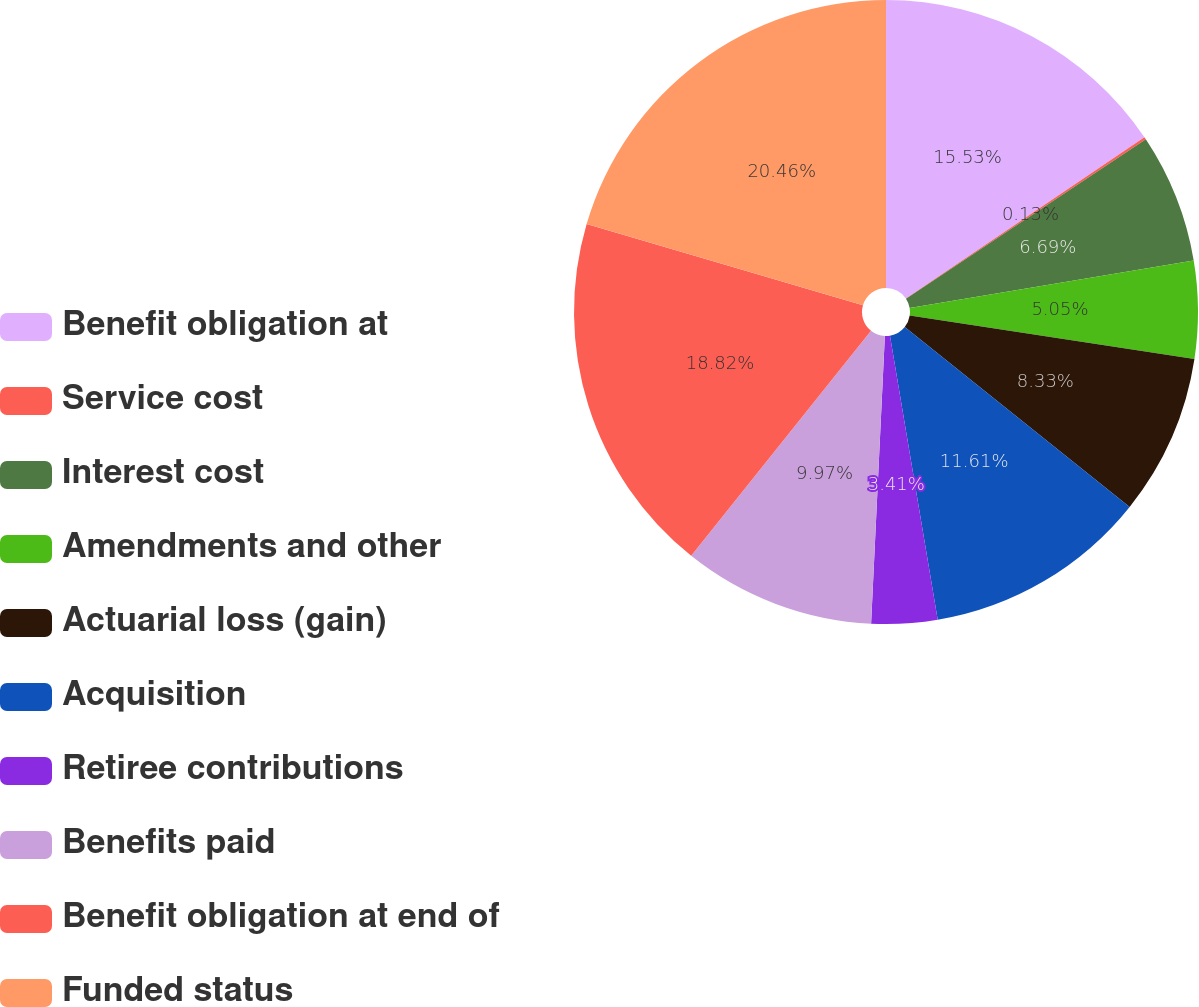<chart> <loc_0><loc_0><loc_500><loc_500><pie_chart><fcel>Benefit obligation at<fcel>Service cost<fcel>Interest cost<fcel>Amendments and other<fcel>Actuarial loss (gain)<fcel>Acquisition<fcel>Retiree contributions<fcel>Benefits paid<fcel>Benefit obligation at end of<fcel>Funded status<nl><fcel>15.53%<fcel>0.13%<fcel>6.69%<fcel>5.05%<fcel>8.33%<fcel>11.61%<fcel>3.41%<fcel>9.97%<fcel>18.81%<fcel>20.45%<nl></chart> 